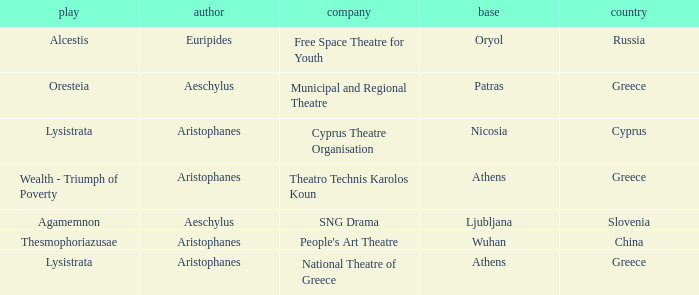What is the name of the company related to aeschylus as the author and greece as the country? Municipal and Regional Theatre. 